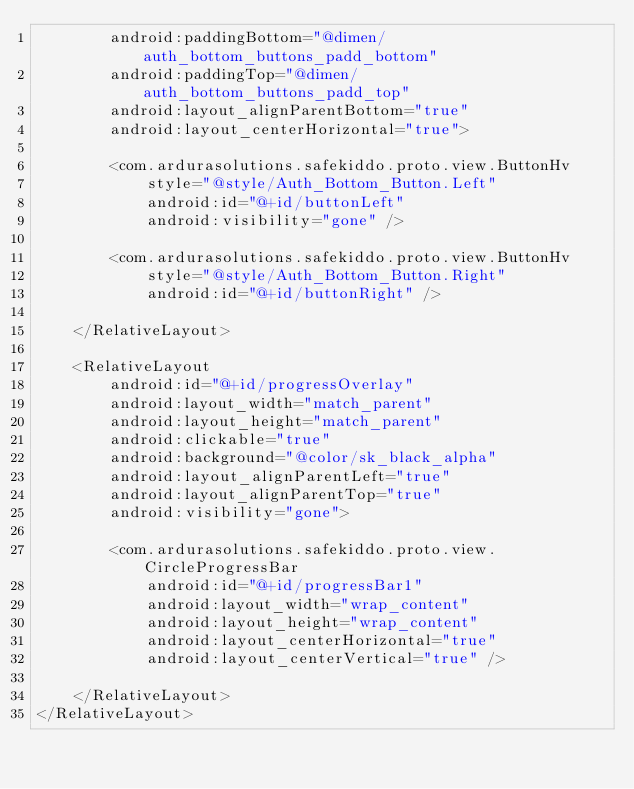Convert code to text. <code><loc_0><loc_0><loc_500><loc_500><_XML_>        android:paddingBottom="@dimen/auth_bottom_buttons_padd_bottom"
        android:paddingTop="@dimen/auth_bottom_buttons_padd_top"
        android:layout_alignParentBottom="true"
        android:layout_centerHorizontal="true">
        
        <com.ardurasolutions.safekiddo.proto.view.ButtonHv
            style="@style/Auth_Bottom_Button.Left"
            android:id="@+id/buttonLeft"
            android:visibility="gone" />
        
        <com.ardurasolutions.safekiddo.proto.view.ButtonHv
            style="@style/Auth_Bottom_Button.Right"
            android:id="@+id/buttonRight" />

    </RelativeLayout>
	
	<RelativeLayout 
	    android:id="@+id/progressOverlay"
	    android:layout_width="match_parent"
	    android:layout_height="match_parent"
	    android:clickable="true"
	    android:background="@color/sk_black_alpha"
	    android:layout_alignParentLeft="true"
	    android:layout_alignParentTop="true"
	    android:visibility="gone">
	
	    <com.ardurasolutions.safekiddo.proto.view.CircleProgressBar
            android:id="@+id/progressBar1"
            android:layout_width="wrap_content"
            android:layout_height="wrap_content"
            android:layout_centerHorizontal="true"
            android:layout_centerVertical="true" />
	    
	</RelativeLayout>
</RelativeLayout></code> 